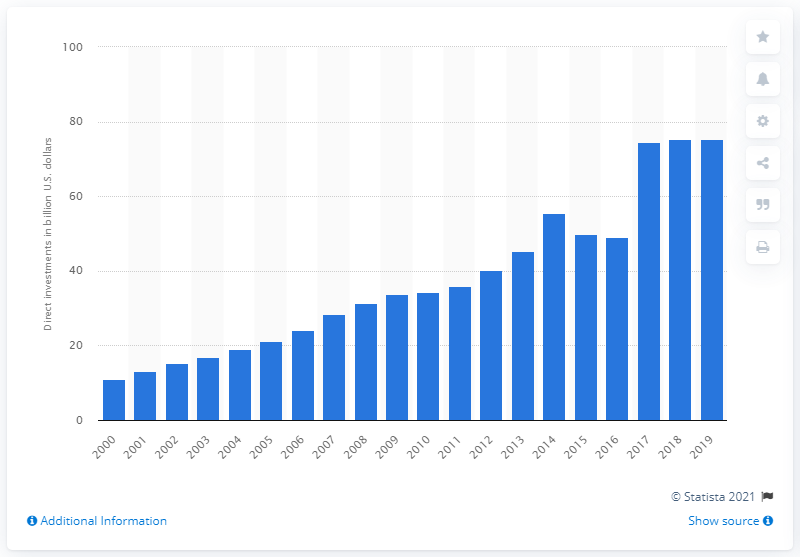Draw attention to some important aspects in this diagram. The value of investments made in the Middle East in 2019 was 75.21... 